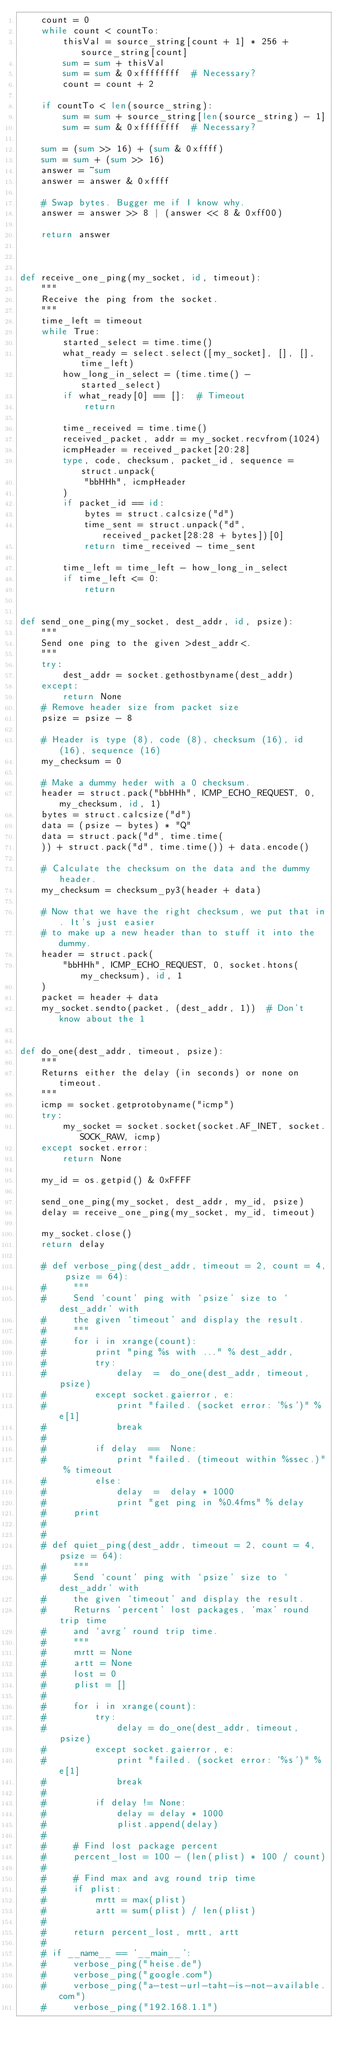<code> <loc_0><loc_0><loc_500><loc_500><_Python_>    count = 0
    while count < countTo:
        thisVal = source_string[count + 1] * 256 + source_string[count]
        sum = sum + thisVal
        sum = sum & 0xffffffff  # Necessary?
        count = count + 2

    if countTo < len(source_string):
        sum = sum + source_string[len(source_string) - 1]
        sum = sum & 0xffffffff  # Necessary?

    sum = (sum >> 16) + (sum & 0xffff)
    sum = sum + (sum >> 16)
    answer = ~sum
    answer = answer & 0xffff

    # Swap bytes. Bugger me if I know why.
    answer = answer >> 8 | (answer << 8 & 0xff00)

    return answer



def receive_one_ping(my_socket, id, timeout):
    """
    Receive the ping from the socket.
    """
    time_left = timeout
    while True:
        started_select = time.time()
        what_ready = select.select([my_socket], [], [], time_left)
        how_long_in_select = (time.time() - started_select)
        if what_ready[0] == []:  # Timeout
            return

        time_received = time.time()
        received_packet, addr = my_socket.recvfrom(1024)
        icmpHeader = received_packet[20:28]
        type, code, checksum, packet_id, sequence = struct.unpack(
            "bbHHh", icmpHeader
        )
        if packet_id == id:
            bytes = struct.calcsize("d")
            time_sent = struct.unpack("d", received_packet[28:28 + bytes])[0]
            return time_received - time_sent

        time_left = time_left - how_long_in_select
        if time_left <= 0:
            return


def send_one_ping(my_socket, dest_addr, id, psize):
    """
    Send one ping to the given >dest_addr<.
    """
    try:
        dest_addr = socket.gethostbyname(dest_addr)
    except:
        return None
    # Remove header size from packet size
    psize = psize - 8

    # Header is type (8), code (8), checksum (16), id (16), sequence (16)
    my_checksum = 0

    # Make a dummy heder with a 0 checksum.
    header = struct.pack("bbHHh", ICMP_ECHO_REQUEST, 0, my_checksum, id, 1)
    bytes = struct.calcsize("d")
    data = (psize - bytes) * "Q"
    data = struct.pack("d", time.time(
    )) + struct.pack("d", time.time()) + data.encode()

    # Calculate the checksum on the data and the dummy header.
    my_checksum = checksum_py3(header + data)

    # Now that we have the right checksum, we put that in. It's just easier
    # to make up a new header than to stuff it into the dummy.
    header = struct.pack(
        "bbHHh", ICMP_ECHO_REQUEST, 0, socket.htons(my_checksum), id, 1
    )
    packet = header + data
    my_socket.sendto(packet, (dest_addr, 1))  # Don't know about the 1


def do_one(dest_addr, timeout, psize):
    """
    Returns either the delay (in seconds) or none on timeout.
    """
    icmp = socket.getprotobyname("icmp")
    try:
        my_socket = socket.socket(socket.AF_INET, socket.SOCK_RAW, icmp)
    except socket.error:
        return None

    my_id = os.getpid() & 0xFFFF

    send_one_ping(my_socket, dest_addr, my_id, psize)
    delay = receive_one_ping(my_socket, my_id, timeout)

    my_socket.close()
    return delay

    # def verbose_ping(dest_addr, timeout = 2, count = 4, psize = 64):
    #     """
    #     Send `count' ping with `psize' size to `dest_addr' with
    #     the given `timeout' and display the result.
    #     """
    #     for i in xrange(count):
    #         print "ping %s with ..." % dest_addr,
    #         try:
    #             delay  =  do_one(dest_addr, timeout, psize)
    #         except socket.gaierror, e:
    #             print "failed. (socket error: '%s')" % e[1]
    #             break
    #
    #         if delay  ==  None:
    #             print "failed. (timeout within %ssec.)" % timeout
    #         else:
    #             delay  =  delay * 1000
    #             print "get ping in %0.4fms" % delay
    #     print
    #
    #
    # def quiet_ping(dest_addr, timeout = 2, count = 4, psize = 64):
    #     """
    #     Send `count' ping with `psize' size to `dest_addr' with
    #     the given `timeout' and display the result.
    #     Returns `percent' lost packages, `max' round trip time
    #     and `avrg' round trip time.
    #     """
    #     mrtt = None
    #     artt = None
    #     lost = 0
    #     plist = []
    #
    #     for i in xrange(count):
    #         try:
    #             delay = do_one(dest_addr, timeout, psize)
    #         except socket.gaierror, e:
    #             print "failed. (socket error: '%s')" % e[1]
    #             break
    #
    #         if delay != None:
    #             delay = delay * 1000
    #             plist.append(delay)
    #
    #     # Find lost package percent
    #     percent_lost = 100 - (len(plist) * 100 / count)
    #
    #     # Find max and avg round trip time
    #     if plist:
    #         mrtt = max(plist)
    #         artt = sum(plist) / len(plist)
    #
    #     return percent_lost, mrtt, artt
    #
    # if __name__ == '__main__':
    #     verbose_ping("heise.de")
    #     verbose_ping("google.com")
    #     verbose_ping("a-test-url-taht-is-not-available.com")
    #     verbose_ping("192.168.1.1")
</code> 